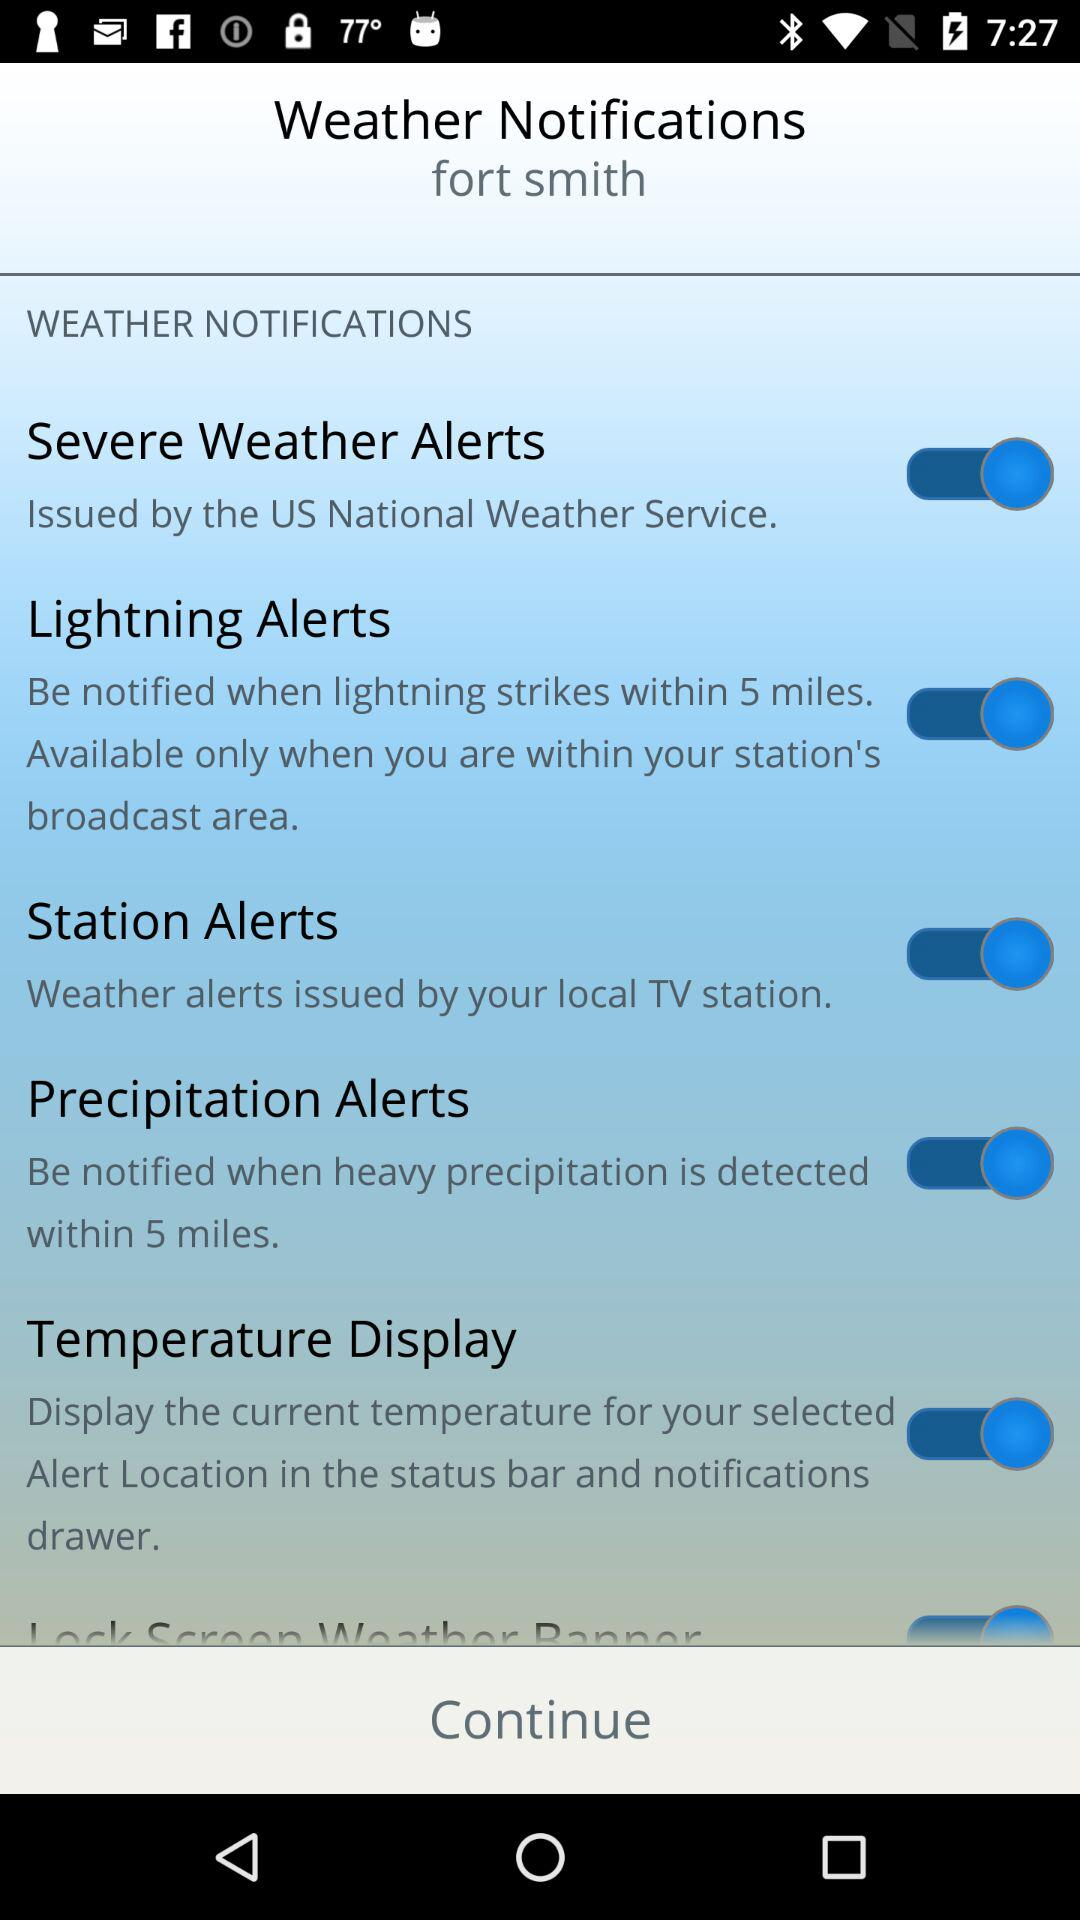Who issues severe weather alerts? Severe weather alerts are issued by the US National Weather Service. 